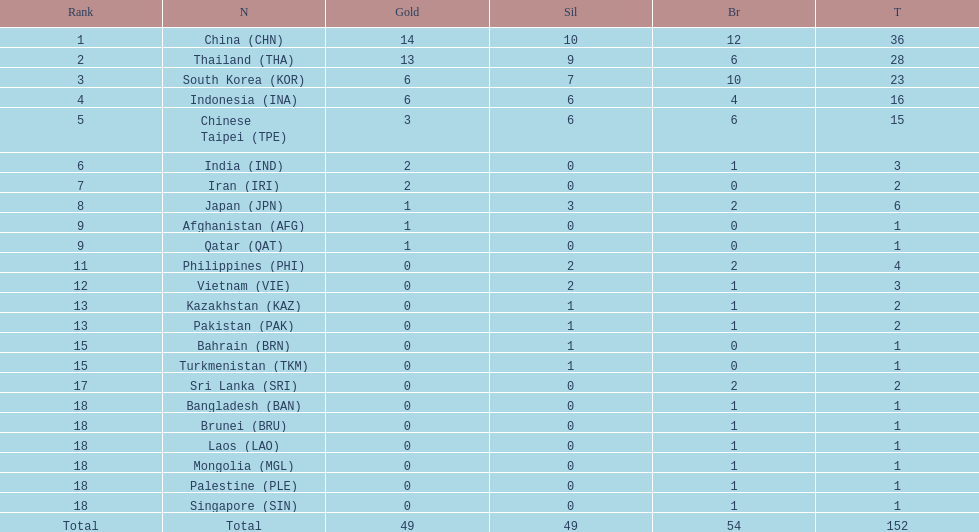Did the philippines or kazakhstan have a higher number of total medals? Philippines. 